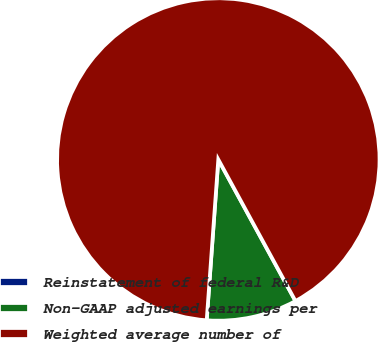Convert chart to OTSL. <chart><loc_0><loc_0><loc_500><loc_500><pie_chart><fcel>Reinstatement of federal R&D<fcel>Non-GAAP adjusted earnings per<fcel>Weighted average number of<nl><fcel>0.0%<fcel>9.09%<fcel>90.91%<nl></chart> 